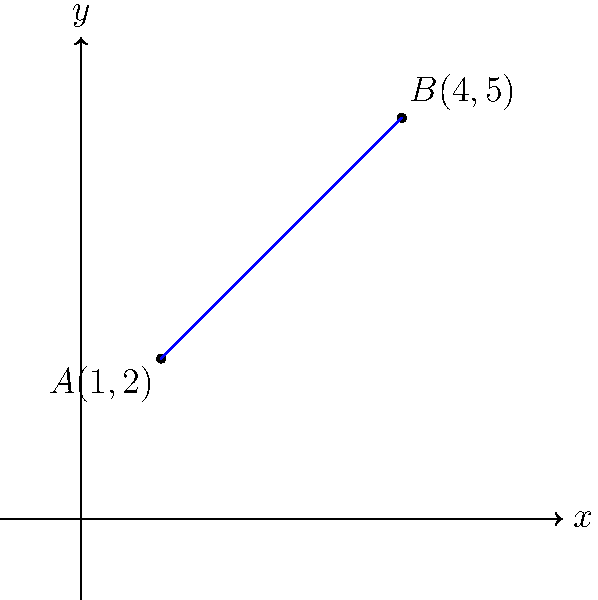Bernice, remember how we used to solve math problems together in class? Here's one that reminds me of your artistic eye for lines and angles. In the coordinate plane above, points A(1,2) and B(4,5) are connected by a blue line. What is the slope of this line? Let's approach this step-by-step, just like we used to do in class:

1) The slope of a line can be calculated using the formula:
   
   $m = \frac{y_2 - y_1}{x_2 - x_1}$

   where $(x_1, y_1)$ and $(x_2, y_2)$ are two points on the line.

2) We have two points:
   A(1,2) and B(4,5)

3) Let's assign our values:
   $(x_1, y_1) = (1, 2)$
   $(x_2, y_2) = (4, 5)$

4) Now, let's plug these into our slope formula:

   $m = \frac{y_2 - y_1}{x_2 - x_1} = \frac{5 - 2}{4 - 1}$

5) Simplify:
   $m = \frac{3}{3}$

6) Calculate:
   $m = 1$

Therefore, the slope of the line connecting points A and B is 1.
Answer: 1 